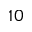Convert formula to latex. <formula><loc_0><loc_0><loc_500><loc_500>1 0</formula> 